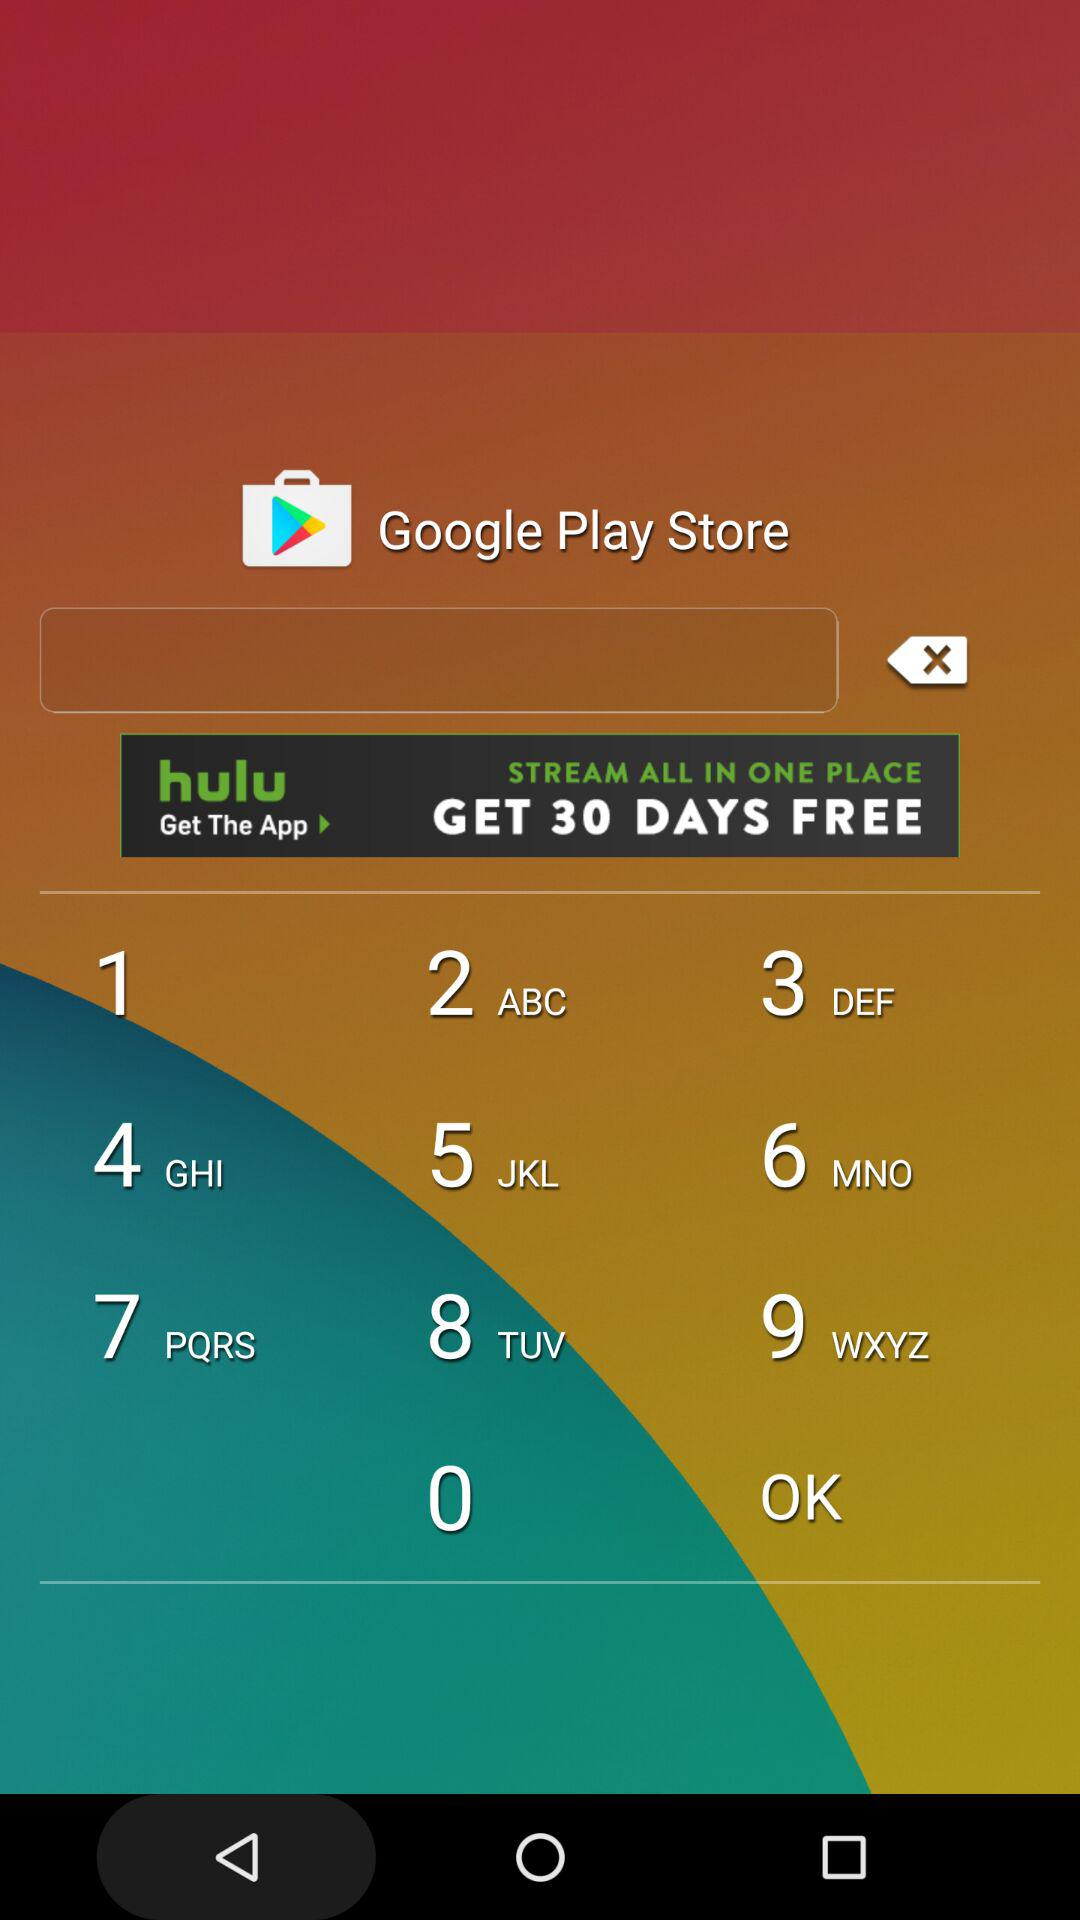What is the purse for race 4?
Answer the question using a single word or phrase. $40,000 